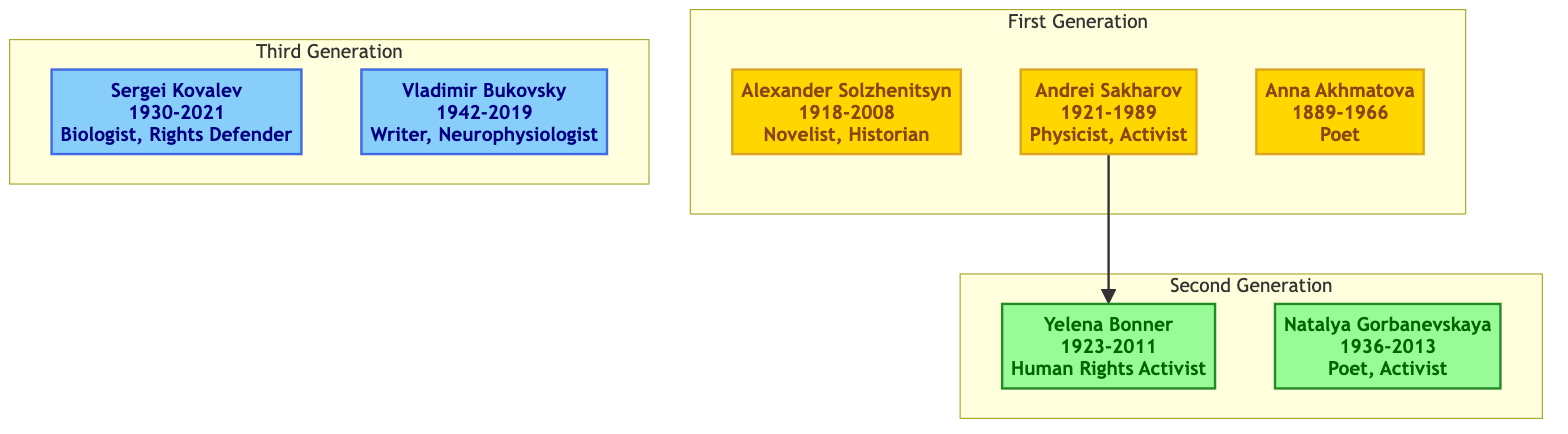What is the occupation of Alexander Solzhenitsyn? The diagram indicates that Alexander Solzhenitsyn is described as a Novelist and Historian.
Answer: Novelist, Historian Who is the mother of Yelena Bonner? The diagram shows that Yelena Bonner is related to Andrei Sakharov, who is her spouse. However, there is no mention of Yelena Bonner's mother in the diagram, indicating that this information is not directly represented.
Answer: Not specified How many generations are represented in the diagram? By counting the number of distinct groups labeled as "First Generation", "Second Generation", and "Third Generation", we find there are three generations represented in the diagram.
Answer: 3 What notable work is associated with Anna Akhmatova? The diagram points out that Anna Akhmatova's notable work is "Requiem".
Answer: Requiem Which individual is associated with the notable work "To Build a Castle: My Life as a Dissenter"? The diagram identifies Vladimir Bukovsky as the individual associated with this notable work.
Answer: Vladimir Bukovsky What is the birth year of Yelena Bonner? The diagram explicitly states that Yelena Bonner was born in 1923.
Answer: 1923 Which poet and civil rights activist is included in the Second Generation? The diagram includes Natalya Gorbanevskaya as the poet and civil rights activist in the Second Generation.
Answer: Natalya Gorbanevskaya Who directly connects the First Generation to the Second Generation in the diagram? The diagram shows that Andrei Sakharov directly connects to Yelena Bonner within the family tree, indicating their relationship.
Answer: Andrei Sakharov What is the occupation of Sergei Kovalev? The diagram describes Sergei Kovalev as a Biologist and Human Rights Defender.
Answer: Biologist, Human Rights Defender 